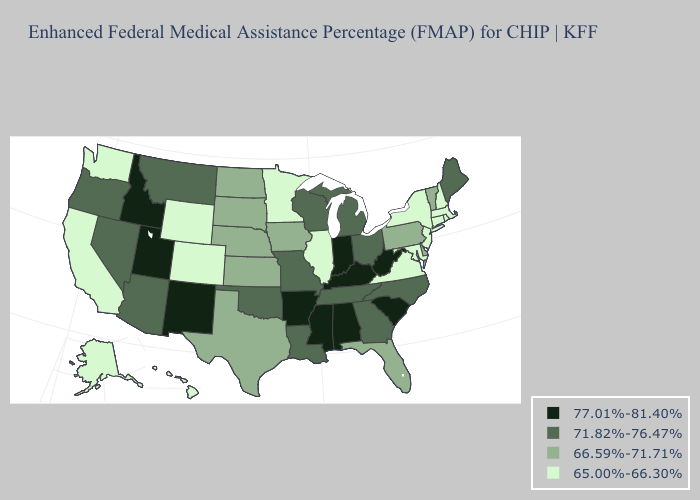What is the value of Massachusetts?
Short answer required. 65.00%-66.30%. Does Delaware have the highest value in the USA?
Write a very short answer. No. Name the states that have a value in the range 71.82%-76.47%?
Keep it brief. Arizona, Georgia, Louisiana, Maine, Michigan, Missouri, Montana, Nevada, North Carolina, Ohio, Oklahoma, Oregon, Tennessee, Wisconsin. What is the value of New Jersey?
Quick response, please. 65.00%-66.30%. Name the states that have a value in the range 65.00%-66.30%?
Concise answer only. Alaska, California, Colorado, Connecticut, Hawaii, Illinois, Maryland, Massachusetts, Minnesota, New Hampshire, New Jersey, New York, Rhode Island, Virginia, Washington, Wyoming. Which states have the lowest value in the MidWest?
Keep it brief. Illinois, Minnesota. Name the states that have a value in the range 66.59%-71.71%?
Keep it brief. Delaware, Florida, Iowa, Kansas, Nebraska, North Dakota, Pennsylvania, South Dakota, Texas, Vermont. What is the value of Vermont?
Write a very short answer. 66.59%-71.71%. Name the states that have a value in the range 66.59%-71.71%?
Give a very brief answer. Delaware, Florida, Iowa, Kansas, Nebraska, North Dakota, Pennsylvania, South Dakota, Texas, Vermont. What is the lowest value in the USA?
Concise answer only. 65.00%-66.30%. Which states have the highest value in the USA?
Be succinct. Alabama, Arkansas, Idaho, Indiana, Kentucky, Mississippi, New Mexico, South Carolina, Utah, West Virginia. Does Maine have the same value as North Carolina?
Quick response, please. Yes. Name the states that have a value in the range 71.82%-76.47%?
Quick response, please. Arizona, Georgia, Louisiana, Maine, Michigan, Missouri, Montana, Nevada, North Carolina, Ohio, Oklahoma, Oregon, Tennessee, Wisconsin. Among the states that border North Carolina , does South Carolina have the lowest value?
Be succinct. No. Among the states that border Illinois , does Missouri have the highest value?
Keep it brief. No. 